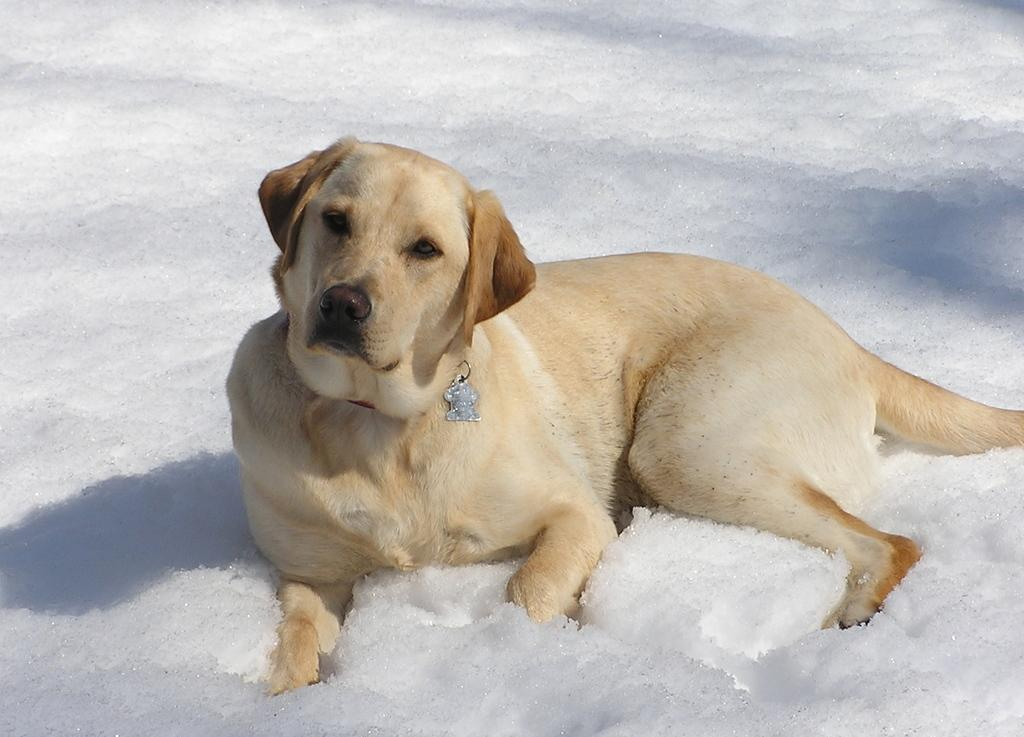What animal is present in the image? There is a dog in the image. What is the dog doing in the image? The dog is laying on the snow. What type of plantation can be seen in the background of the image? There is no plantation present in the image; it features a dog laying on the snow. 